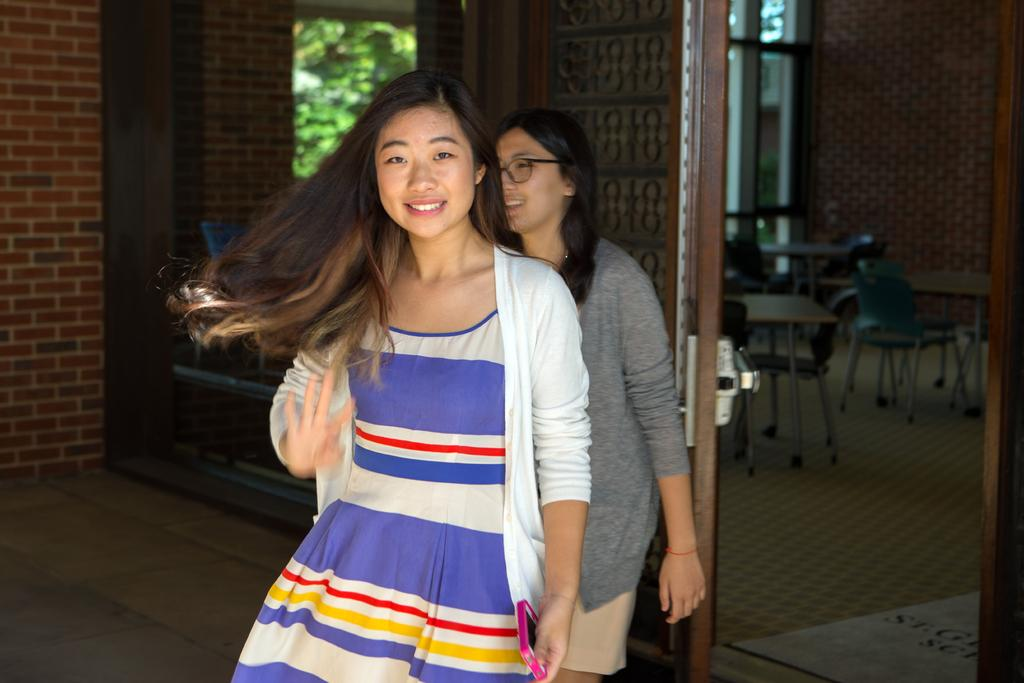What is the appearance of the woman in the foreground of the image? There is a woman with long hair in the image. Can you describe the setting of the image? The image appears to be taken outside of a classroom. Are there any other people visible in the image? Yes, there is another woman in the background of the image. What type of holiday is being celebrated by the giants in the image? There are no giants present in the image, and therefore no holiday can be observed. What is the length of the nose on the woman in the image? The length of the nose on the woman in the image is not mentioned in the provided facts, so it cannot be determined. 